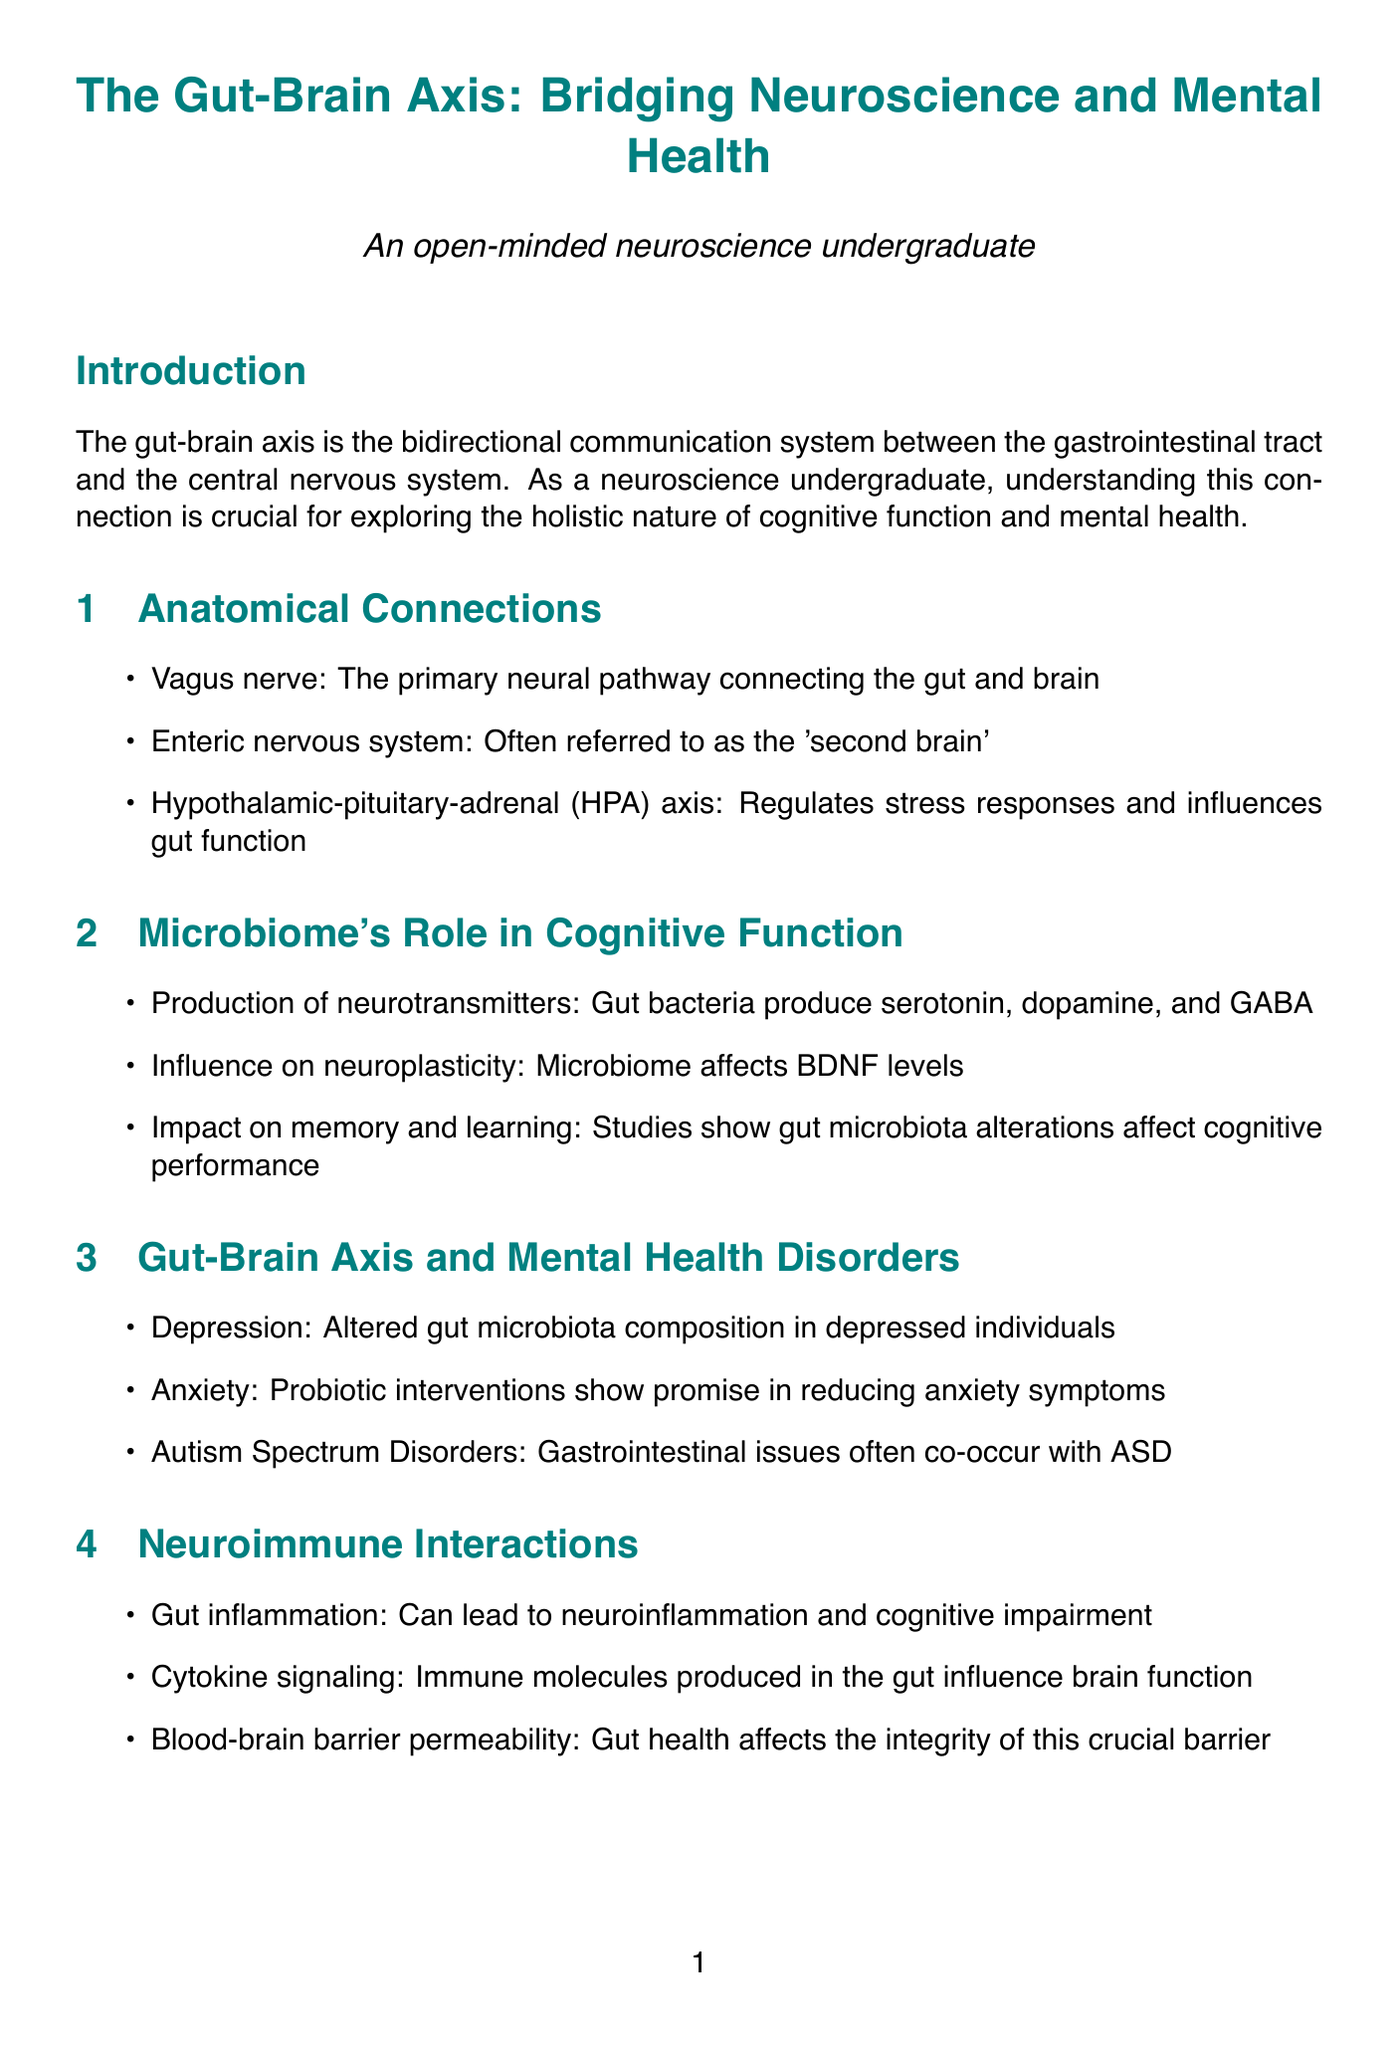What is the definition of the gut-brain axis? The definition is provided in the introduction section of the document, stating that it is the bidirectional communication system between the gastrointestinal tract and the central nervous system.
Answer: bidirectional communication system between the gastrointestinal tract and the central nervous system What is often referred to as the 'second brain'? The document lists the enteric nervous system in the section about anatomical connections, describing it as the 'second brain'.
Answer: enteric nervous system Which neurotransmitters do gut bacteria produce? This information is found in the section discussing the microbiome's role in cognitive function, specifically listing the neurotransmitters produced by gut bacteria.
Answer: serotonin, dopamine, and GABA What dietary component is mentioned to support beneficial gut bacteria? The section on dietary influences explicitly mentions fermentable fibers as supporting beneficial gut bacteria.
Answer: fermentable fibers How is the gut-brain axis related to anxiety treatment? The document suggests that probiotic interventions show promise in reducing anxiety symptoms in the section about gut-brain axis and mental health disorders.
Answer: Probiotic interventions In which study is fecal microbiota transplantation examined as a treatment? The document lists the Cork University Hospital Depression and Microbiome Project as focusing on the efficacy of fecal microbiota transplantation for treatment-resistant depression.
Answer: Cork University Hospital Depression and Microbiome Project Who is a leading researcher in psychobiotics? The document identifies Dr. John Cryan as a leading researcher in psychobiotics and stress-related disorders.
Answer: Dr. John Cryan What future direction involves creating specific probiotic strains? The future directions section mentions psychobiotics in the context of developing specific probiotic strains for mental health.
Answer: Psychobiotics What does the conclusion highlight about the gut-brain axis? The conclusion summarizes the gut-brain axis as a paradigm shift in understanding cognitive function and mental health, challenging a traditional view.
Answer: paradigm shift in our understanding of cognitive function and mental health 